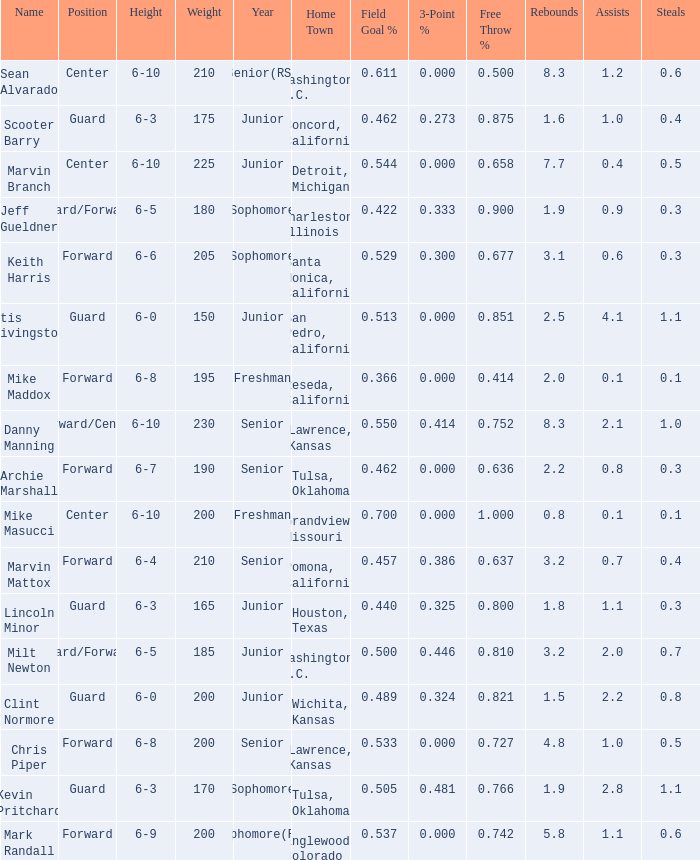Can you tell me the average Weight that has Height of 6-9? 200.0. 